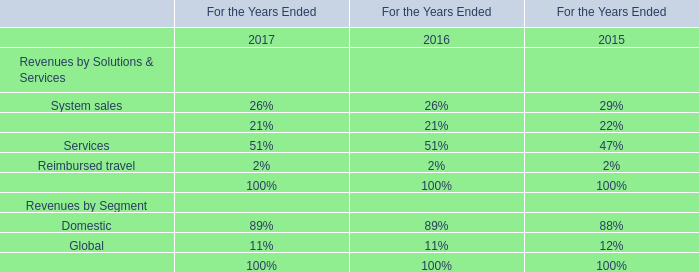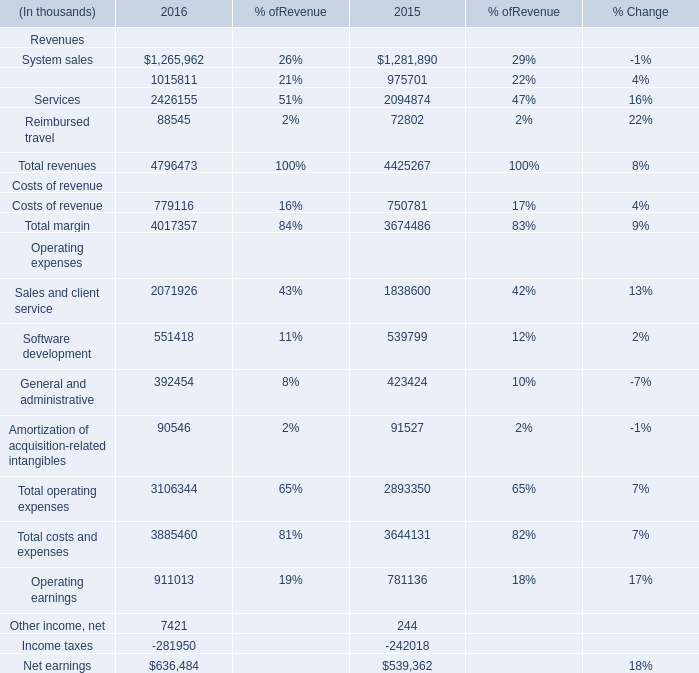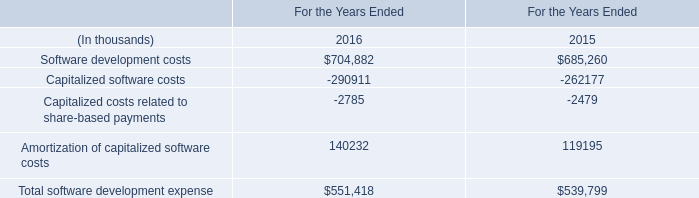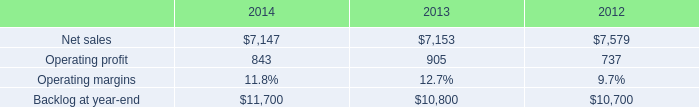What's the sum of Software development costs of For the Years Ended 2015, and Income taxes Operating expenses of 2015 ? 
Computations: (685260.0 + 242018.0)
Answer: 927278.0. 